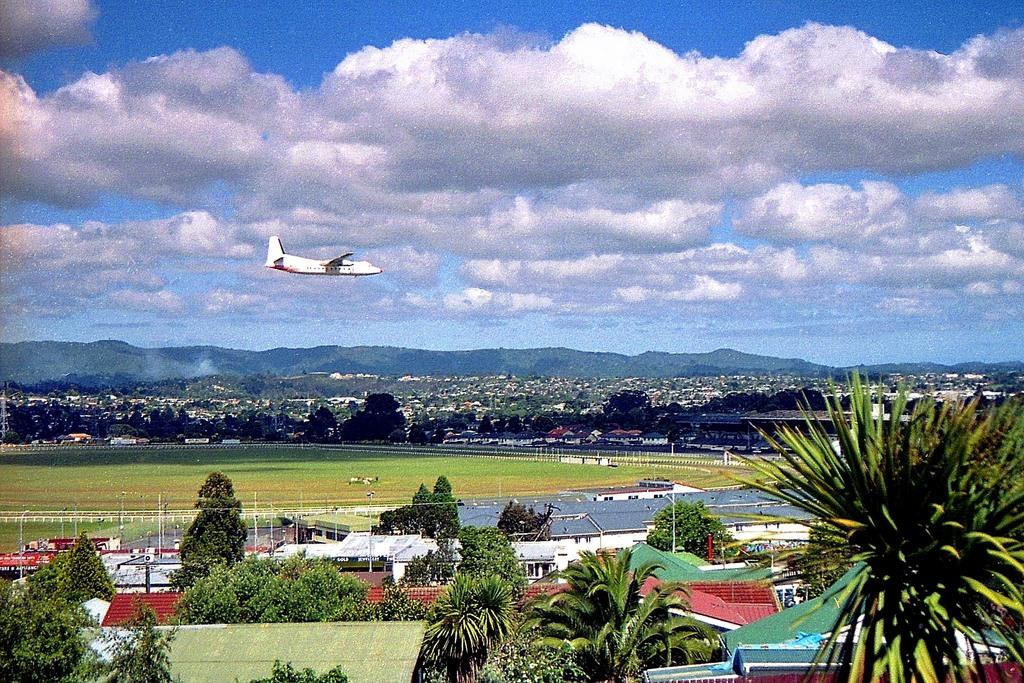What type of natural elements can be seen in the image? There are trees in the image. What type of man-made structures are present in the image? There are buildings in the image. What is the surface on which the trees and buildings are situated? There is a ground visible in the image. What can be seen in the distance in the image? There are hills in the background of the image. What is visible above the hills in the image? The sky is visible in the background of the image. Can you describe any moving objects in the sky? There is an aeroplane flying in the sky. What type of bubble can be seen floating near the trees in the image? There is no bubble present in the image; it only features trees, buildings, ground, hills, sky, and an aeroplane. Can you tell me which judge is responsible for the design of the buildings in the image? There is no information about a judge or the design process of the buildings in the image. 